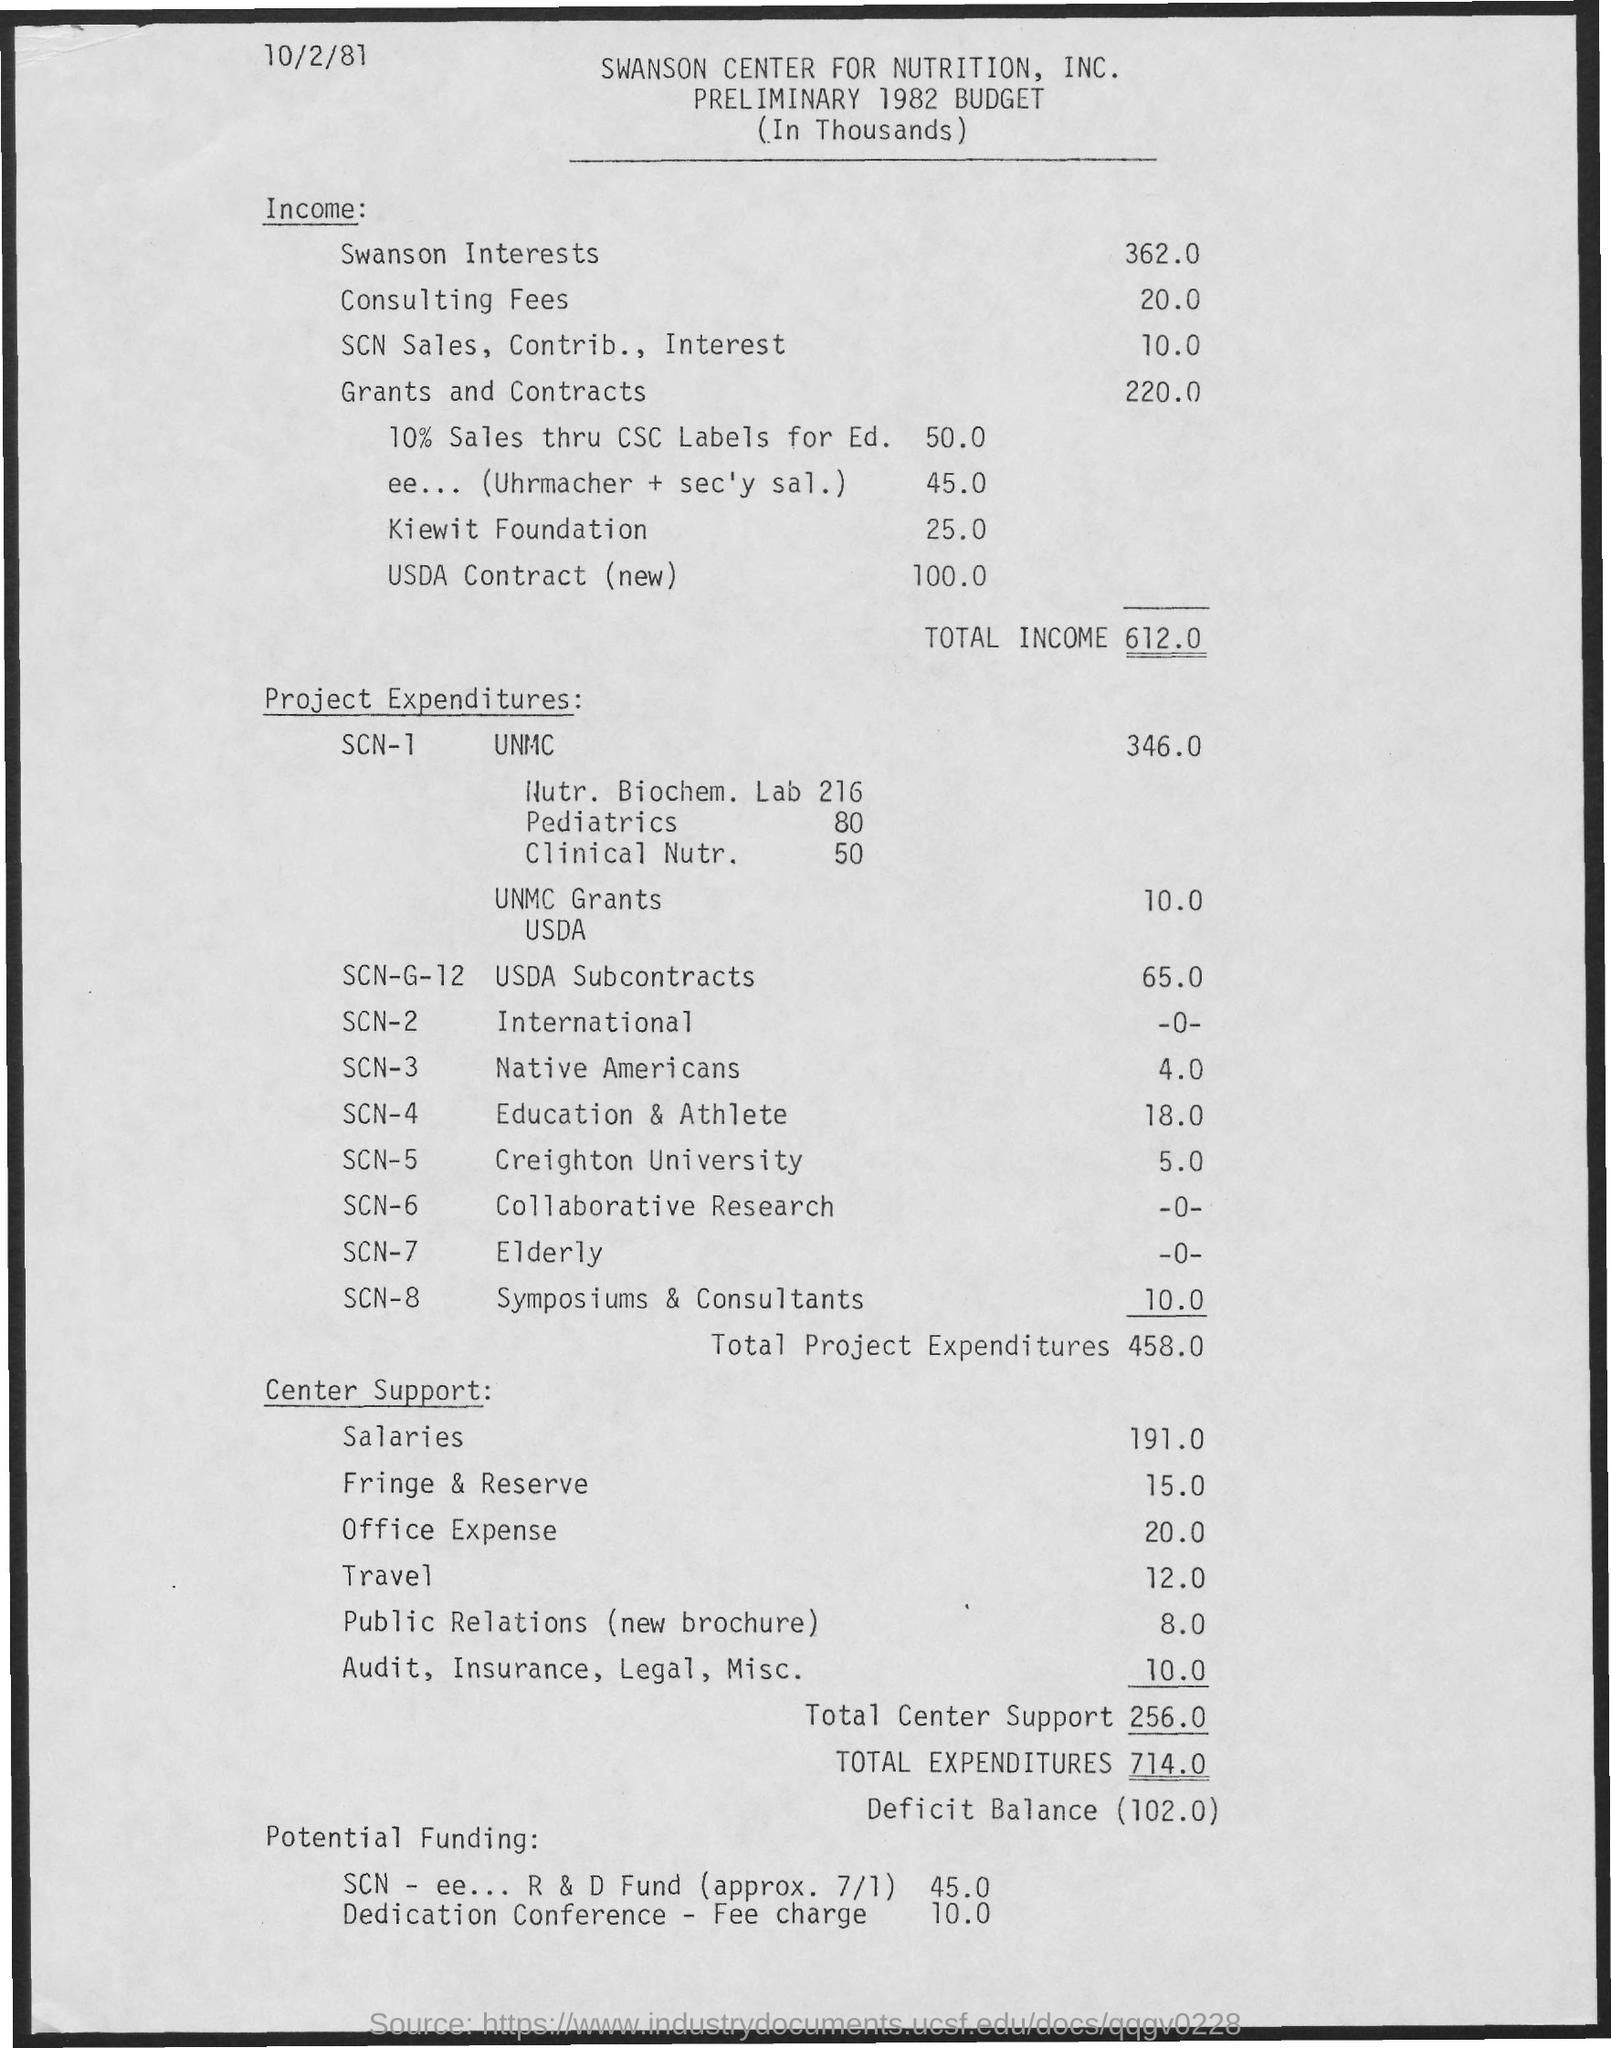What is the date on the document?
Keep it short and to the point. 10/2/81. What is the Income for Swanson Interests?
Your response must be concise. 362.0. What is the Consulting Fees?
Ensure brevity in your answer.  20.0. What is the SCN Sales, Contrib., Interest?
Offer a very short reply. 10.0. What is the Grants and contracts?
Offer a terse response. 220.0. What is the Total Income?
Your answer should be very brief. 612.0. What is the Total Project expenditures?
Provide a succinct answer. 458.0. What is the Total Center Support?
Offer a very short reply. 256.0. What is the Total expenditures?
Your answer should be very brief. 714.0. What is the Deficit Balance?
Your answer should be compact. 102.0. 